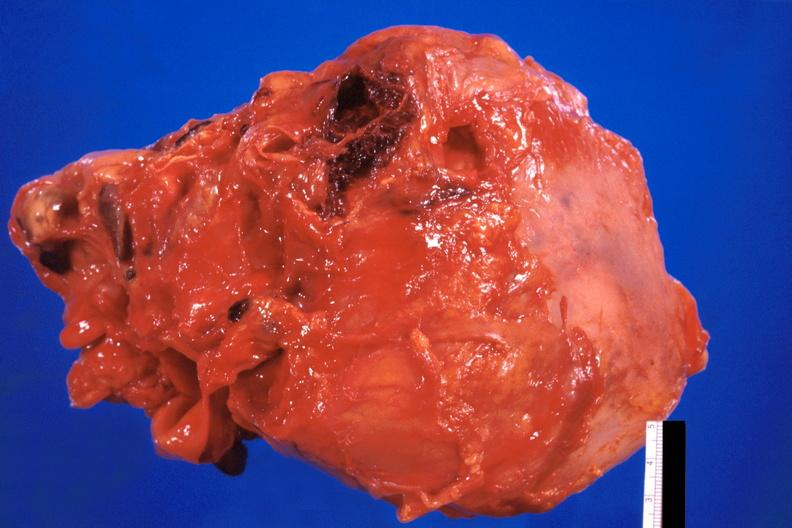what is present?
Answer the question using a single word or phrase. Cardiovascular 